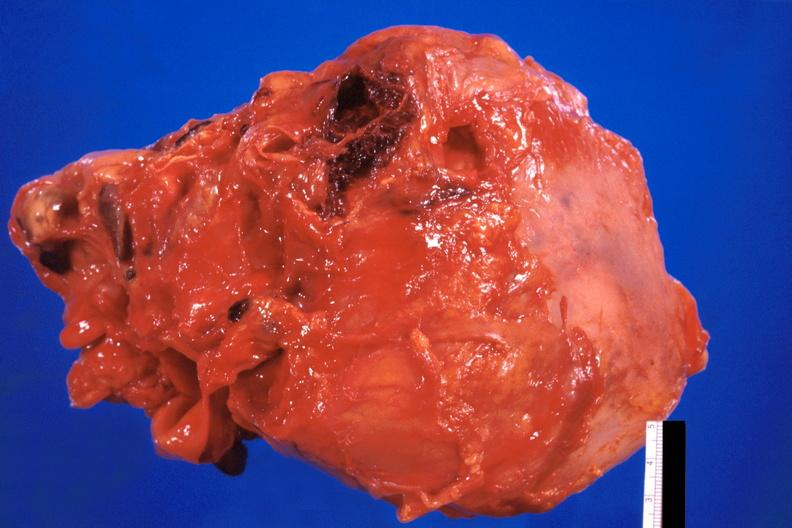what is present?
Answer the question using a single word or phrase. Cardiovascular 